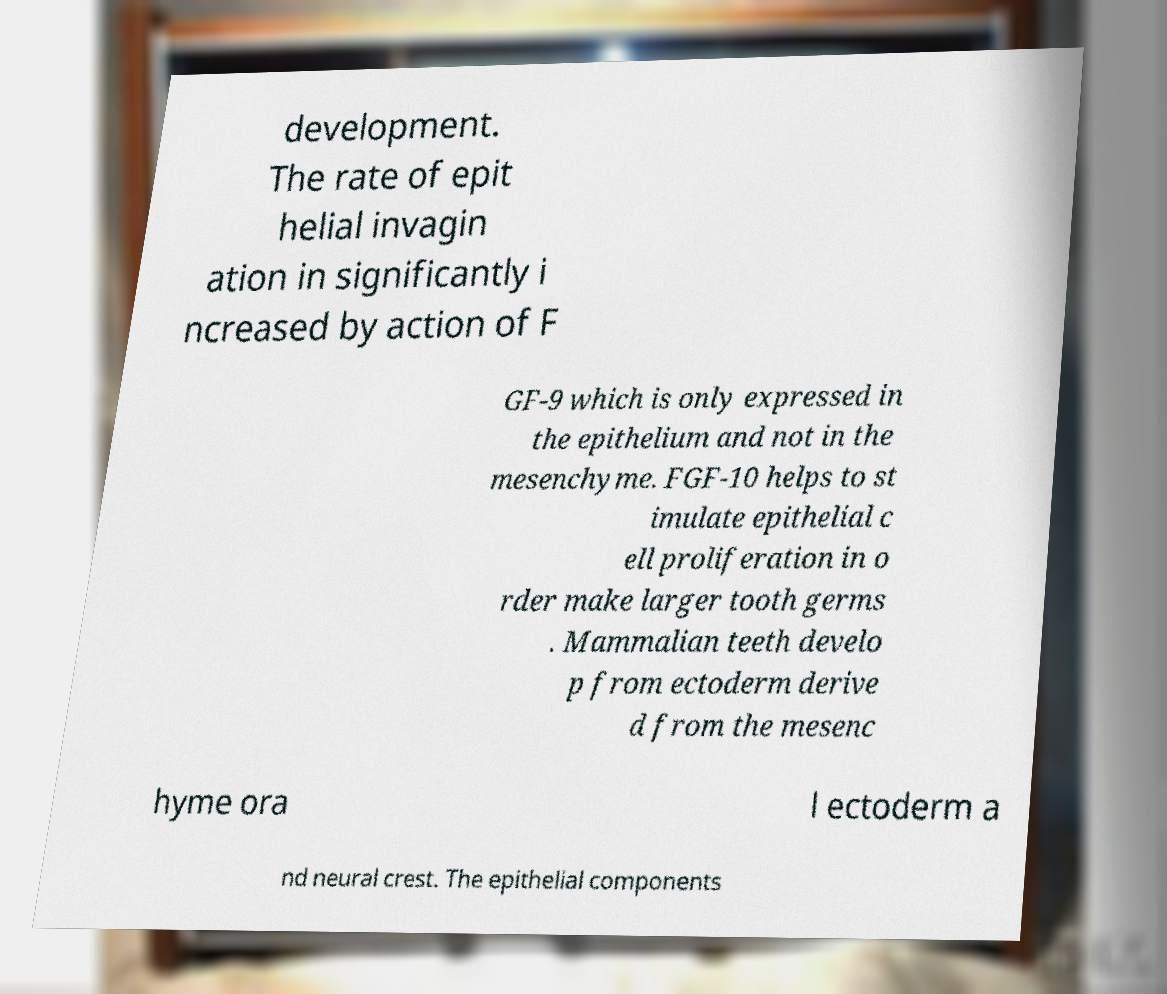For documentation purposes, I need the text within this image transcribed. Could you provide that? development. The rate of epit helial invagin ation in significantly i ncreased by action of F GF-9 which is only expressed in the epithelium and not in the mesenchyme. FGF-10 helps to st imulate epithelial c ell proliferation in o rder make larger tooth germs . Mammalian teeth develo p from ectoderm derive d from the mesenc hyme ora l ectoderm a nd neural crest. The epithelial components 